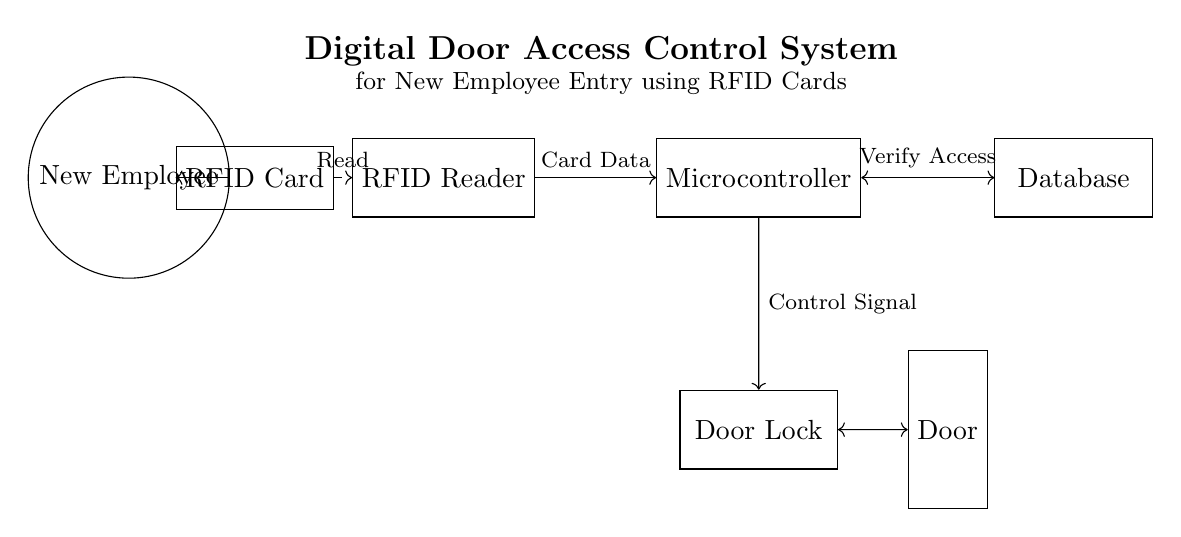What component is used to read RFID cards? The circuit diagram shows an RFID Reader, which is specifically designed to read the data stored in RFID cards. This component connects directly to the RFID Card through a dashed line indicating the read operation.
Answer: RFID Reader What does the microcontroller connect to? The microcontroller connects to both the RFID Reader and the Database. This is shown by two arrows, where one arrow points from the RFID Reader to the microcontroller, and a bidirectional arrow connects the microcontroller to the Database, indicating data exchange.
Answer: RFID Reader, Database What is the purpose of the door lock? The purpose of the door lock is to secure the entry point based on the access control determined by the system. It's shown as a component receiving control signals from the microcontroller and is connected to the door, indicating its role in controlling access.
Answer: Secure entry How is access verified in this system? Access is verified through a communication that takes place between the microcontroller and the Database. The microcontroller sends a verification request to the Database, as indicated by the bidirectional arrow, which allows it to confirm whether the RFID card data corresponds to an authorized entry.
Answer: By the Database What is the initial entity that interacts with the RFID card? The initial entity that interacts with the RFID card is the New Employee, as represented in the diagram. The employee is depicted as a circle and is shown to send a signal to the RFID card to initiate the reading process.
Answer: New Employee 